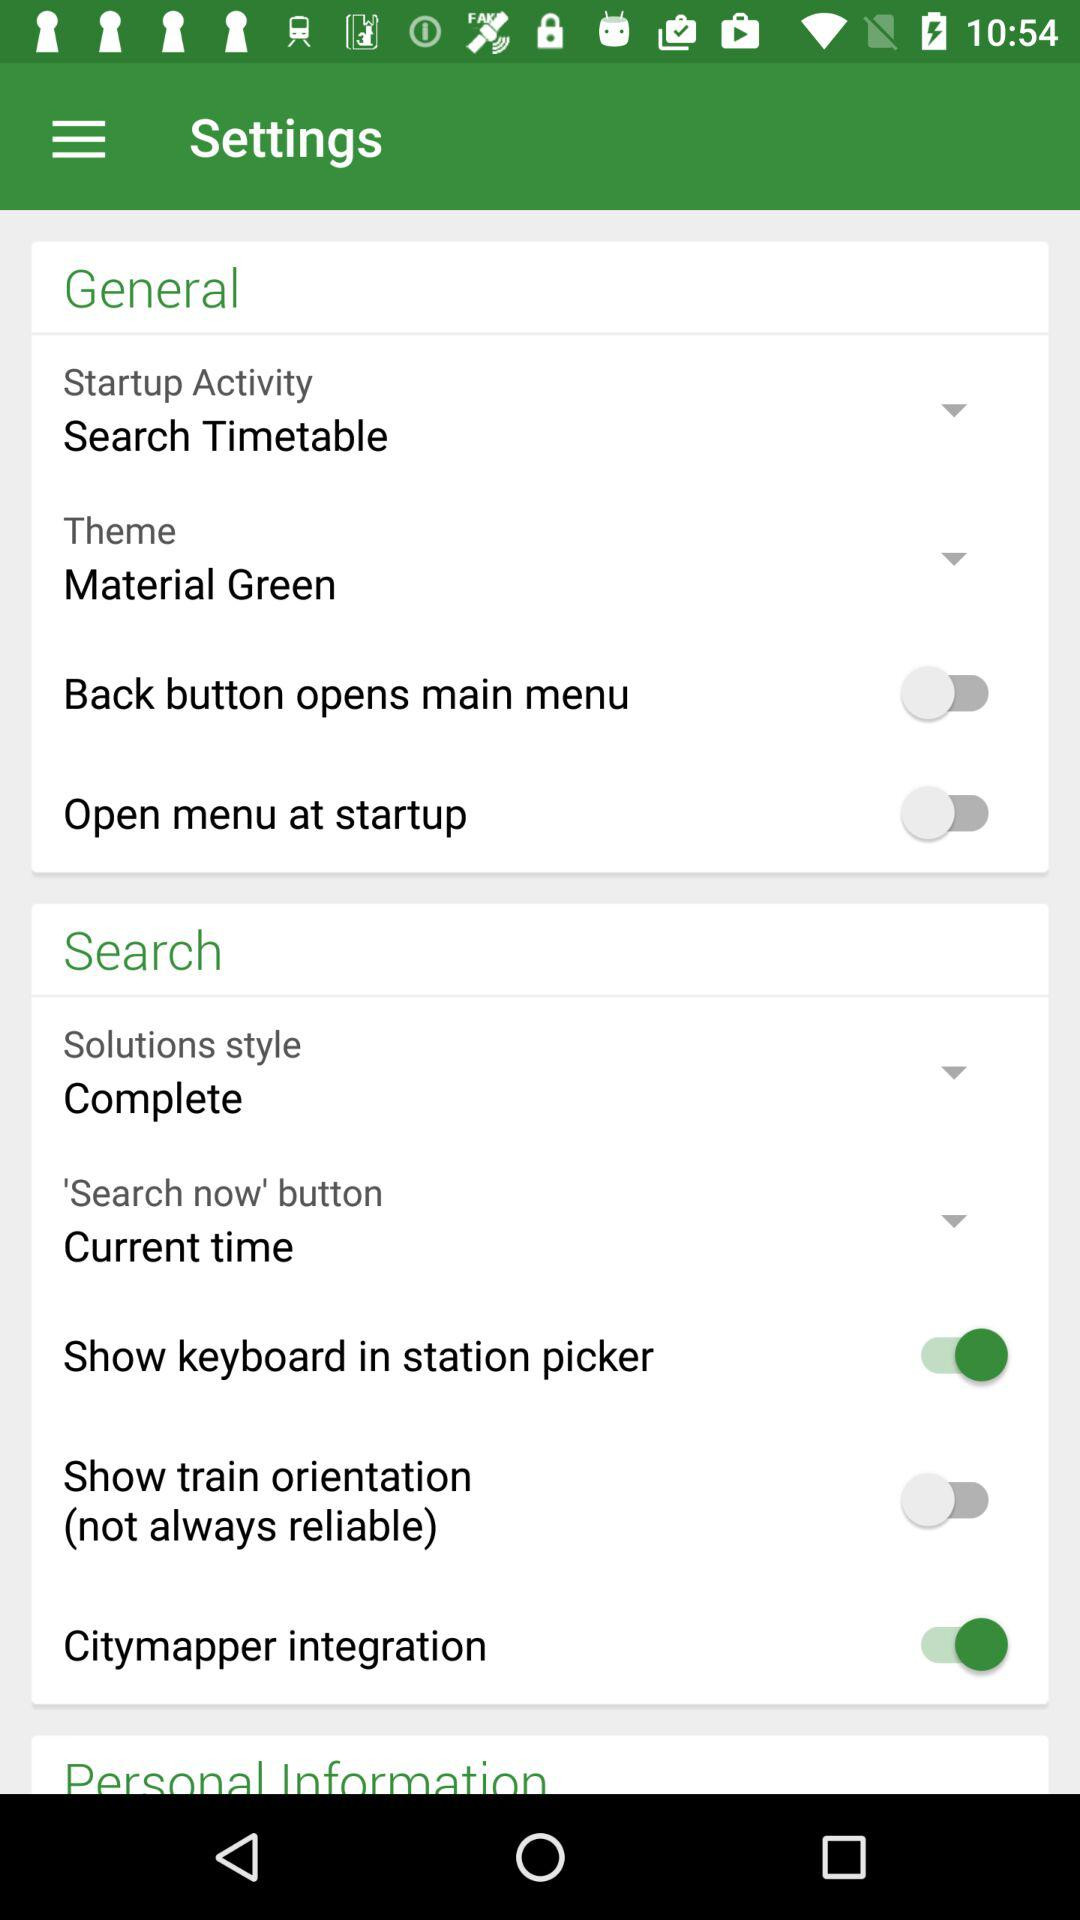What is the status of the "Open menu at startup"? The status is "off". 